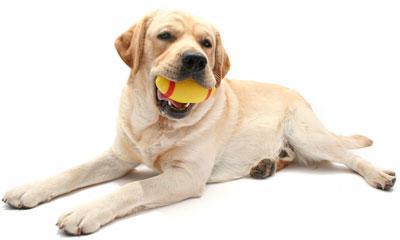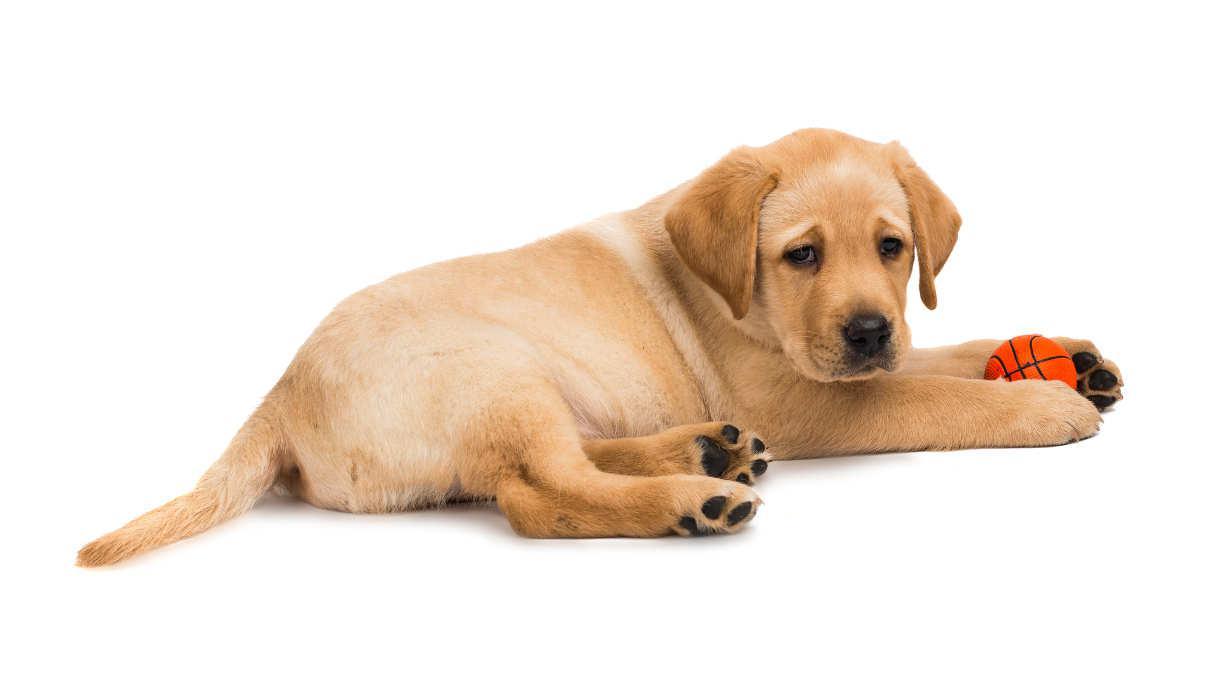The first image is the image on the left, the second image is the image on the right. Analyze the images presented: Is the assertion "In one if the pictures a puppy is laying on a dark cushion." valid? Answer yes or no. No. The first image is the image on the left, the second image is the image on the right. For the images shown, is this caption "An image shows at least one reclining dog wearing something around its neck." true? Answer yes or no. No. 